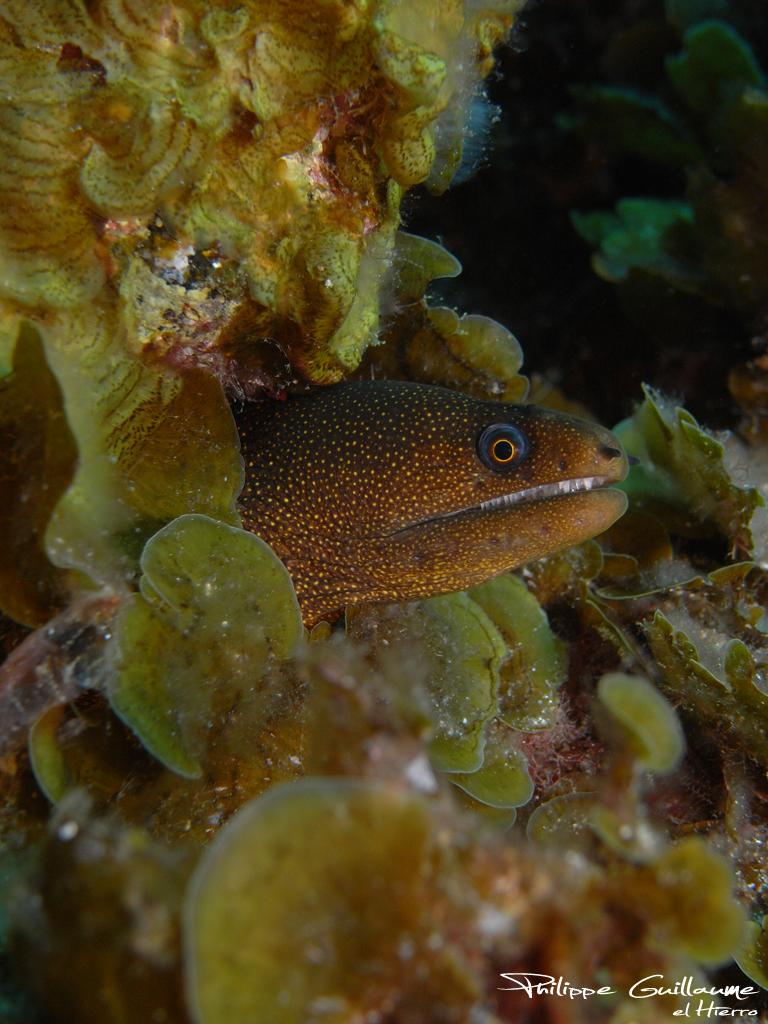What type of animal is present in the image? There is a fish in the image. Can you describe the setting of the image? The environment in the image is underwater. Are there any birthday decorations visible in the image? There are no birthday decorations present in the image, as the environment is underwater and not a party setting. 